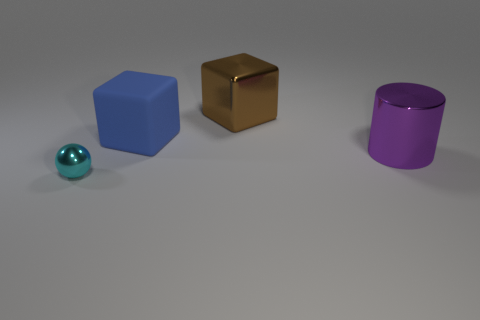How many metallic things are both to the left of the big brown metal block and behind the big purple cylinder?
Make the answer very short. 0. How many gray things are cylinders or large shiny objects?
Ensure brevity in your answer.  0. What color is the metallic thing that is behind the large object to the right of the block that is to the right of the big blue block?
Keep it short and to the point. Brown. Is there a large shiny object that is on the right side of the big metallic thing that is on the left side of the metal cylinder?
Provide a short and direct response. Yes. Is the shape of the shiny object behind the big blue block the same as  the blue thing?
Offer a terse response. Yes. Is there anything else that has the same shape as the purple thing?
Offer a terse response. No. What number of balls are large red objects or big brown metallic things?
Make the answer very short. 0. How many small blue shiny things are there?
Keep it short and to the point. 0. There is a thing that is to the left of the large block in front of the large metal cube; how big is it?
Your answer should be very brief. Small. What number of other things are there of the same size as the purple shiny cylinder?
Provide a succinct answer. 2. 